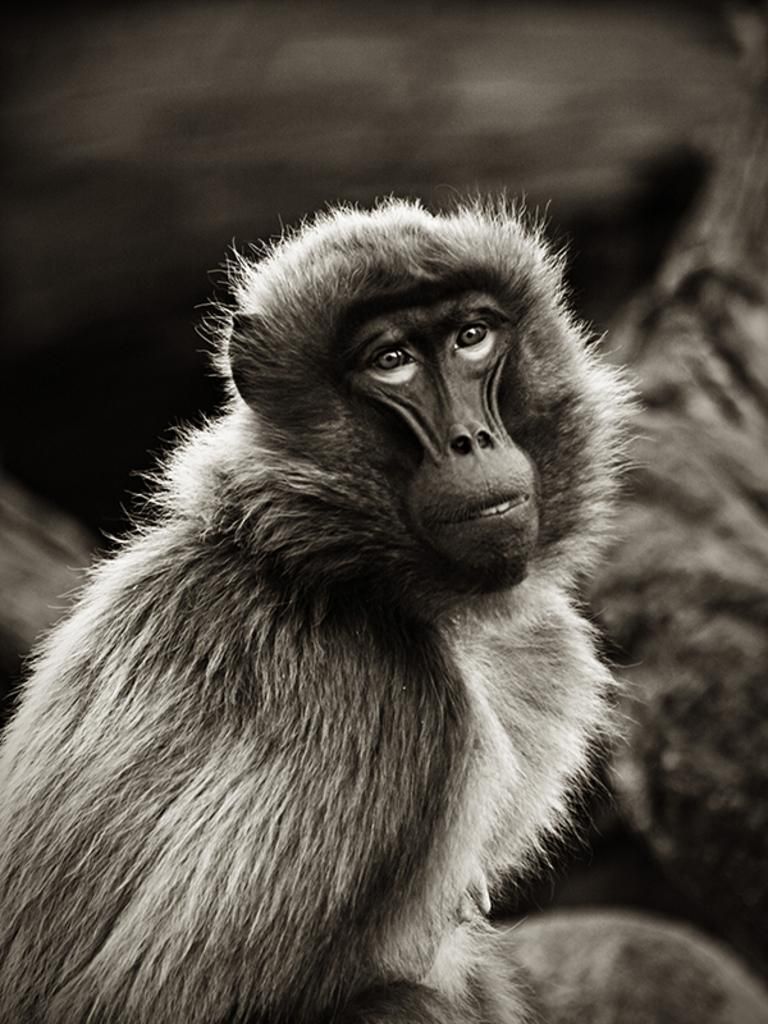What is the color scheme of the image? The image is black and white. What is the main subject in the middle of the image? There is an animal in the middle of the image. What color is the background of the image? The background of the image is black. What type of bag is being discussed by the committee in the image? There is no bag or committee present in the image; it features an animal in the middle of a black background. 